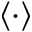Convert formula to latex. <formula><loc_0><loc_0><loc_500><loc_500>\langle \cdot \rangle</formula> 